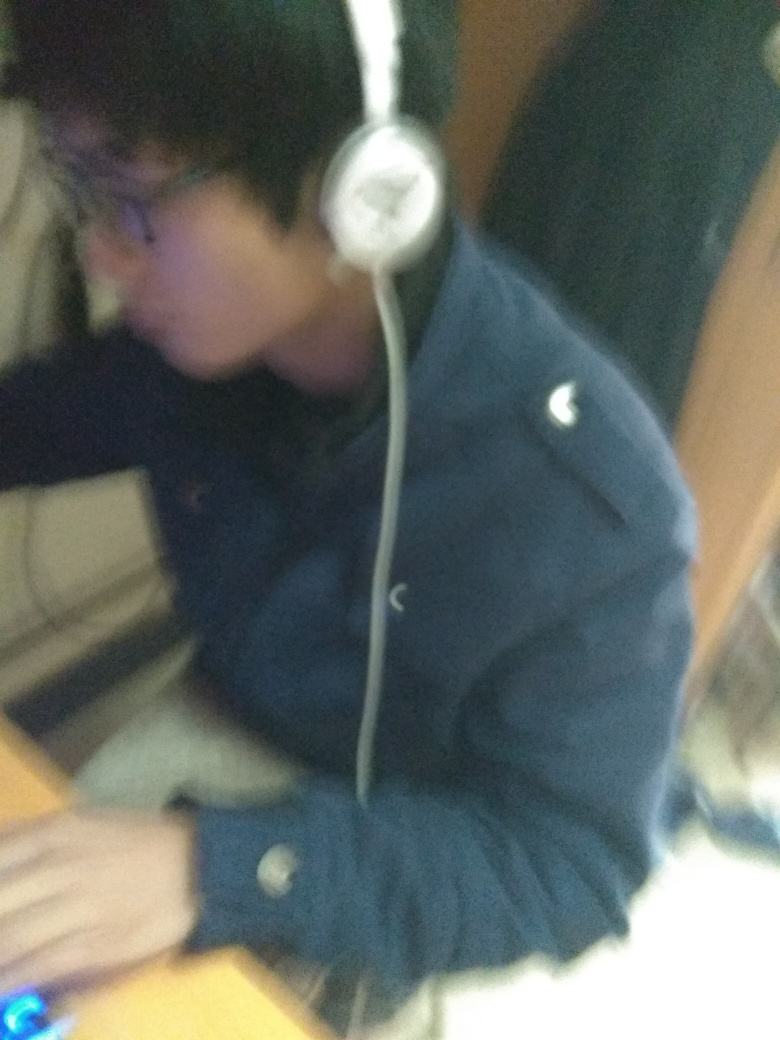What might the person be doing in this image? The person appears to be engaged in an activity at a desk, possibly working or studying, as indicated by their focused posture and the presence of what seems to be a computer mouse on the right. 